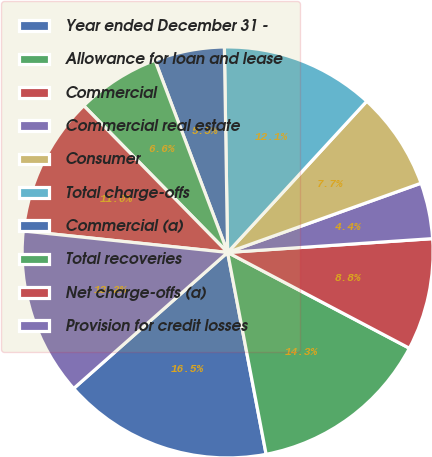Convert chart. <chart><loc_0><loc_0><loc_500><loc_500><pie_chart><fcel>Year ended December 31 -<fcel>Allowance for loan and lease<fcel>Commercial<fcel>Commercial real estate<fcel>Consumer<fcel>Total charge-offs<fcel>Commercial (a)<fcel>Total recoveries<fcel>Net charge-offs (a)<fcel>Provision for credit losses<nl><fcel>16.48%<fcel>14.28%<fcel>8.79%<fcel>4.4%<fcel>7.69%<fcel>12.09%<fcel>5.5%<fcel>6.59%<fcel>10.99%<fcel>13.19%<nl></chart> 